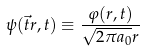Convert formula to latex. <formula><loc_0><loc_0><loc_500><loc_500>\psi ( \vec { t } r , t ) \equiv \frac { \varphi ( r , t ) } { \sqrt { 2 \pi a _ { 0 } } r }</formula> 